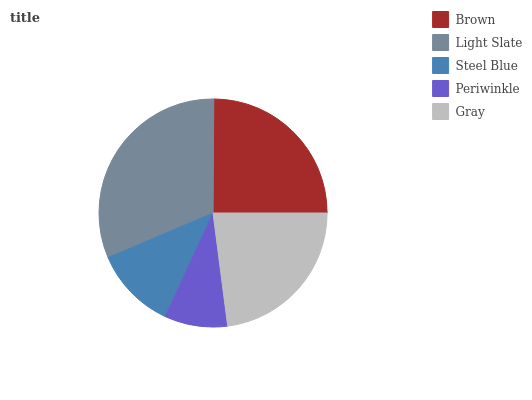Is Periwinkle the minimum?
Answer yes or no. Yes. Is Light Slate the maximum?
Answer yes or no. Yes. Is Steel Blue the minimum?
Answer yes or no. No. Is Steel Blue the maximum?
Answer yes or no. No. Is Light Slate greater than Steel Blue?
Answer yes or no. Yes. Is Steel Blue less than Light Slate?
Answer yes or no. Yes. Is Steel Blue greater than Light Slate?
Answer yes or no. No. Is Light Slate less than Steel Blue?
Answer yes or no. No. Is Gray the high median?
Answer yes or no. Yes. Is Gray the low median?
Answer yes or no. Yes. Is Periwinkle the high median?
Answer yes or no. No. Is Periwinkle the low median?
Answer yes or no. No. 